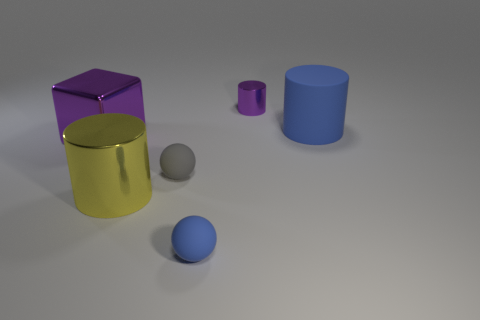Subtract all large blue cylinders. How many cylinders are left? 2 Add 1 small blue rubber things. How many objects exist? 7 Subtract all green cylinders. Subtract all gray spheres. How many cylinders are left? 3 Subtract all cubes. How many objects are left? 5 Add 2 blue matte cylinders. How many blue matte cylinders are left? 3 Add 4 small gray rubber things. How many small gray rubber things exist? 5 Subtract 1 gray spheres. How many objects are left? 5 Subtract all purple cylinders. Subtract all tiny yellow blocks. How many objects are left? 5 